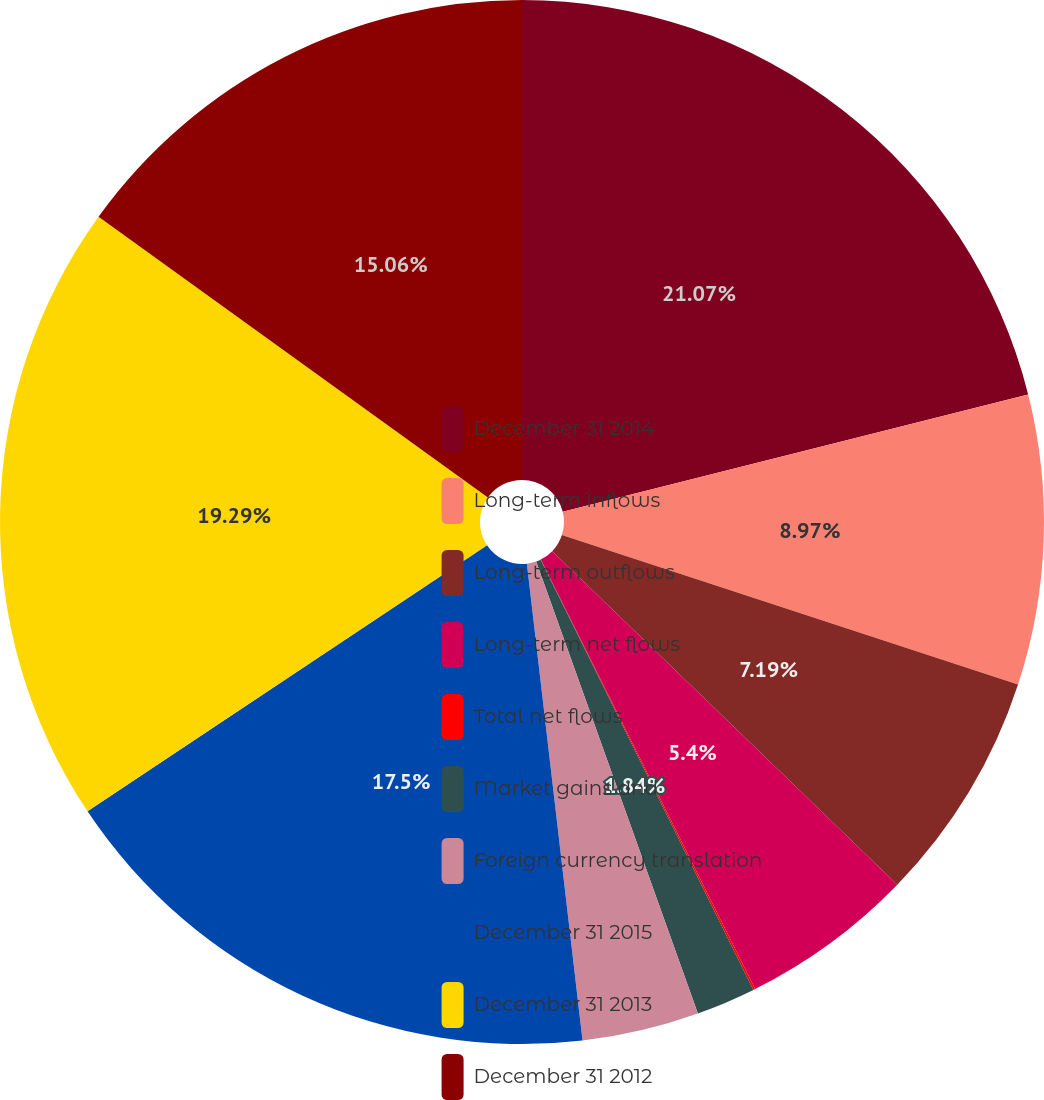Convert chart. <chart><loc_0><loc_0><loc_500><loc_500><pie_chart><fcel>December 31 2014<fcel>Long-term inflows<fcel>Long-term outflows<fcel>Long-term net flows<fcel>Total net flows<fcel>Market gains and<fcel>Foreign currency translation<fcel>December 31 2015<fcel>December 31 2013<fcel>December 31 2012<nl><fcel>21.07%<fcel>8.97%<fcel>7.19%<fcel>5.4%<fcel>0.06%<fcel>1.84%<fcel>3.62%<fcel>17.5%<fcel>19.29%<fcel>15.06%<nl></chart> 